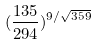<formula> <loc_0><loc_0><loc_500><loc_500>( \frac { 1 3 5 } { 2 9 4 } ) ^ { 9 / \sqrt { 3 5 9 } }</formula> 